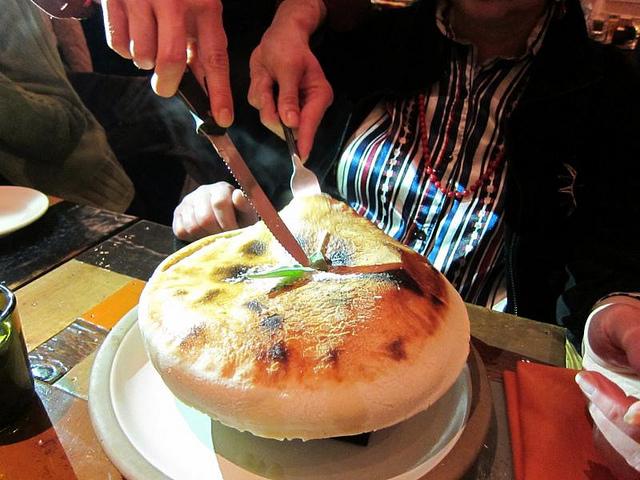What condiments are there?
Write a very short answer. 0. Is this pot pie half eaten?
Answer briefly. No. What kind of food is this?
Concise answer only. Pie. What color is the lady's necklace?
Answer briefly. Red. What kind of knife is being used here?
Keep it brief. Steak knife. Where is the knife?
Give a very brief answer. In hand. Where is the orange napkin?
Answer briefly. Table. 